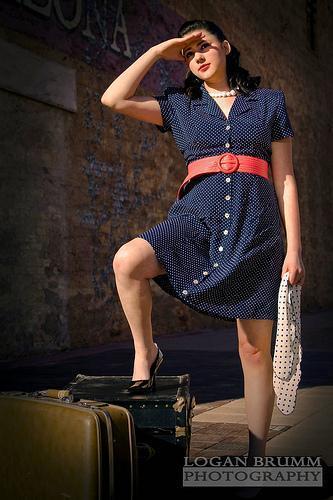How many people are in the image?
Give a very brief answer. 1. How many suitcases in this image do not have a foot on them?
Give a very brief answer. 1. 